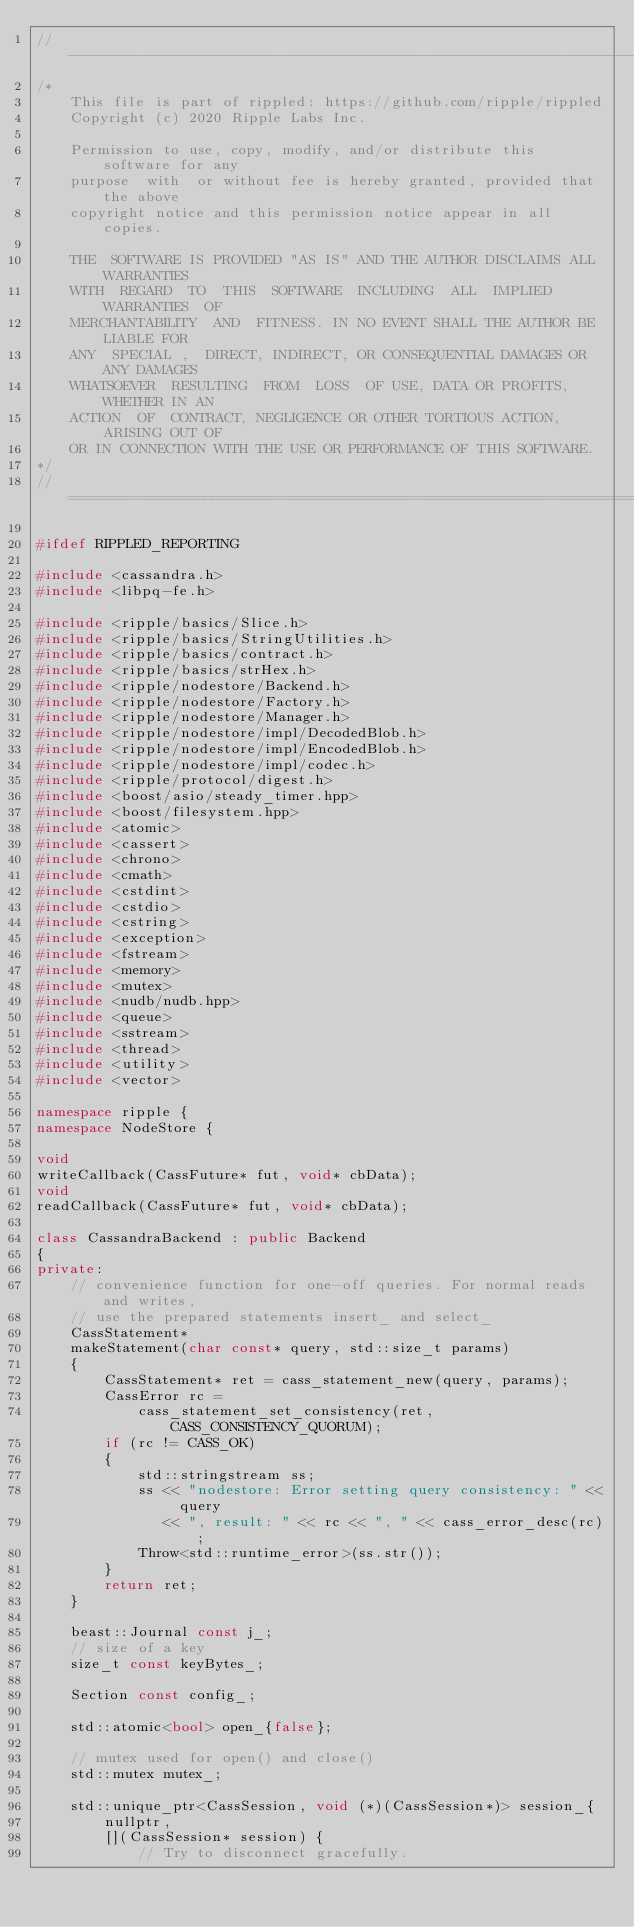Convert code to text. <code><loc_0><loc_0><loc_500><loc_500><_C++_>//------------------------------------------------------------------------------
/*
    This file is part of rippled: https://github.com/ripple/rippled
    Copyright (c) 2020 Ripple Labs Inc.

    Permission to use, copy, modify, and/or distribute this software for any
    purpose  with  or without fee is hereby granted, provided that the above
    copyright notice and this permission notice appear in all copies.

    THE  SOFTWARE IS PROVIDED "AS IS" AND THE AUTHOR DISCLAIMS ALL WARRANTIES
    WITH  REGARD  TO  THIS  SOFTWARE  INCLUDING  ALL  IMPLIED  WARRANTIES  OF
    MERCHANTABILITY  AND  FITNESS. IN NO EVENT SHALL THE AUTHOR BE LIABLE FOR
    ANY  SPECIAL ,  DIRECT, INDIRECT, OR CONSEQUENTIAL DAMAGES OR ANY DAMAGES
    WHATSOEVER  RESULTING  FROM  LOSS  OF USE, DATA OR PROFITS, WHETHER IN AN
    ACTION  OF  CONTRACT, NEGLIGENCE OR OTHER TORTIOUS ACTION, ARISING OUT OF
    OR IN CONNECTION WITH THE USE OR PERFORMANCE OF THIS SOFTWARE.
*/
//==============================================================================

#ifdef RIPPLED_REPORTING

#include <cassandra.h>
#include <libpq-fe.h>

#include <ripple/basics/Slice.h>
#include <ripple/basics/StringUtilities.h>
#include <ripple/basics/contract.h>
#include <ripple/basics/strHex.h>
#include <ripple/nodestore/Backend.h>
#include <ripple/nodestore/Factory.h>
#include <ripple/nodestore/Manager.h>
#include <ripple/nodestore/impl/DecodedBlob.h>
#include <ripple/nodestore/impl/EncodedBlob.h>
#include <ripple/nodestore/impl/codec.h>
#include <ripple/protocol/digest.h>
#include <boost/asio/steady_timer.hpp>
#include <boost/filesystem.hpp>
#include <atomic>
#include <cassert>
#include <chrono>
#include <cmath>
#include <cstdint>
#include <cstdio>
#include <cstring>
#include <exception>
#include <fstream>
#include <memory>
#include <mutex>
#include <nudb/nudb.hpp>
#include <queue>
#include <sstream>
#include <thread>
#include <utility>
#include <vector>

namespace ripple {
namespace NodeStore {

void
writeCallback(CassFuture* fut, void* cbData);
void
readCallback(CassFuture* fut, void* cbData);

class CassandraBackend : public Backend
{
private:
    // convenience function for one-off queries. For normal reads and writes,
    // use the prepared statements insert_ and select_
    CassStatement*
    makeStatement(char const* query, std::size_t params)
    {
        CassStatement* ret = cass_statement_new(query, params);
        CassError rc =
            cass_statement_set_consistency(ret, CASS_CONSISTENCY_QUORUM);
        if (rc != CASS_OK)
        {
            std::stringstream ss;
            ss << "nodestore: Error setting query consistency: " << query
               << ", result: " << rc << ", " << cass_error_desc(rc);
            Throw<std::runtime_error>(ss.str());
        }
        return ret;
    }

    beast::Journal const j_;
    // size of a key
    size_t const keyBytes_;

    Section const config_;

    std::atomic<bool> open_{false};

    // mutex used for open() and close()
    std::mutex mutex_;

    std::unique_ptr<CassSession, void (*)(CassSession*)> session_{
        nullptr,
        [](CassSession* session) {
            // Try to disconnect gracefully.</code> 